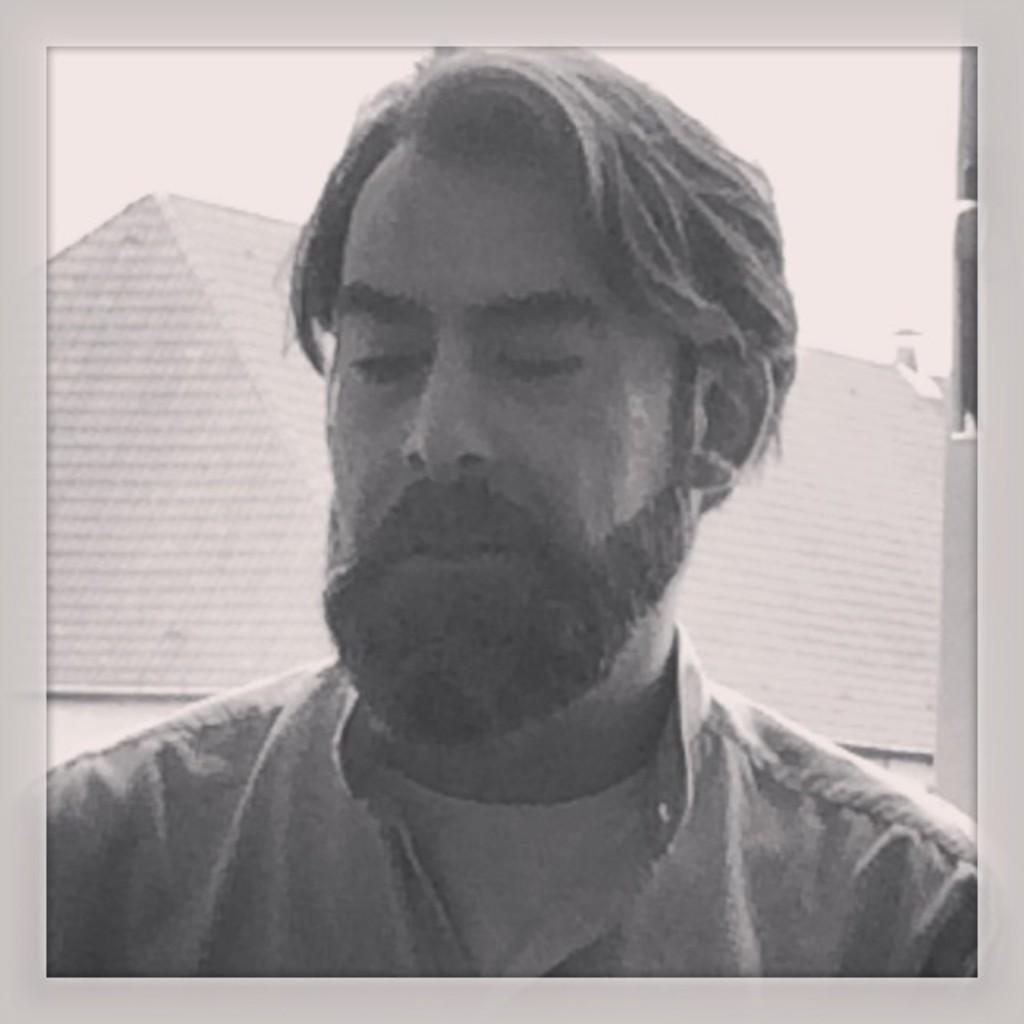How would you summarize this image in a sentence or two? It is a black and white picture. In this picture, we can see a person. Background there is a houses and sky. 